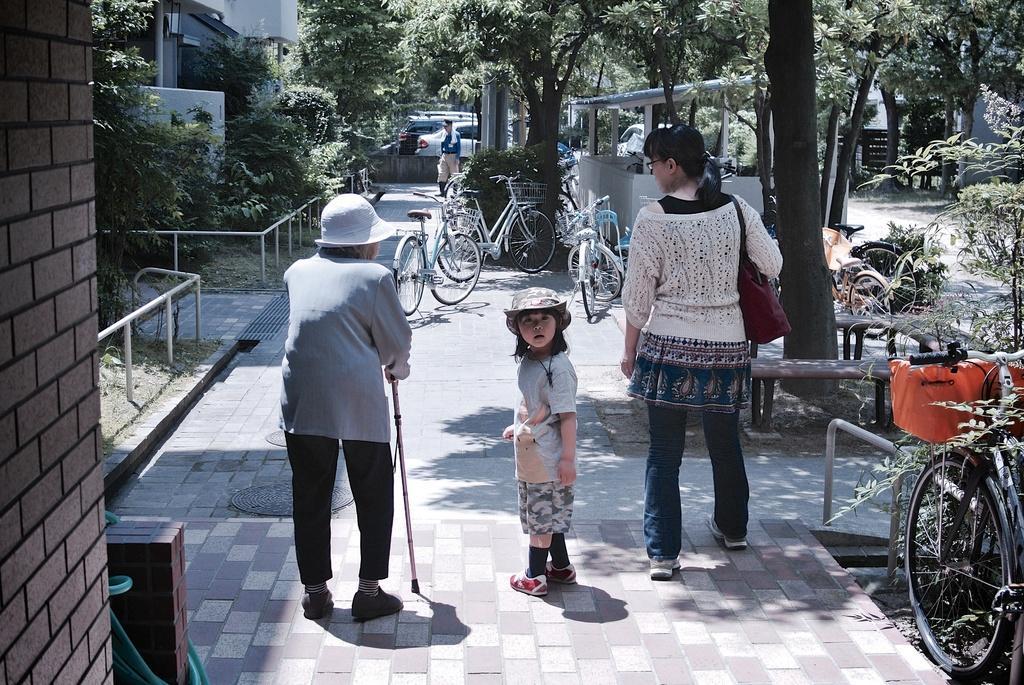Please provide a concise description of this image. In front of the image there is a kid, adult and an old person are walking on the pavement. In front of them there are cycles parked and there is a person walking. On the left side of the image there are plants, metal rod fence, some objects and buildings. On the right side of the image there are trees, a bus shelter and benches. In the background of the image there are cars parked. 